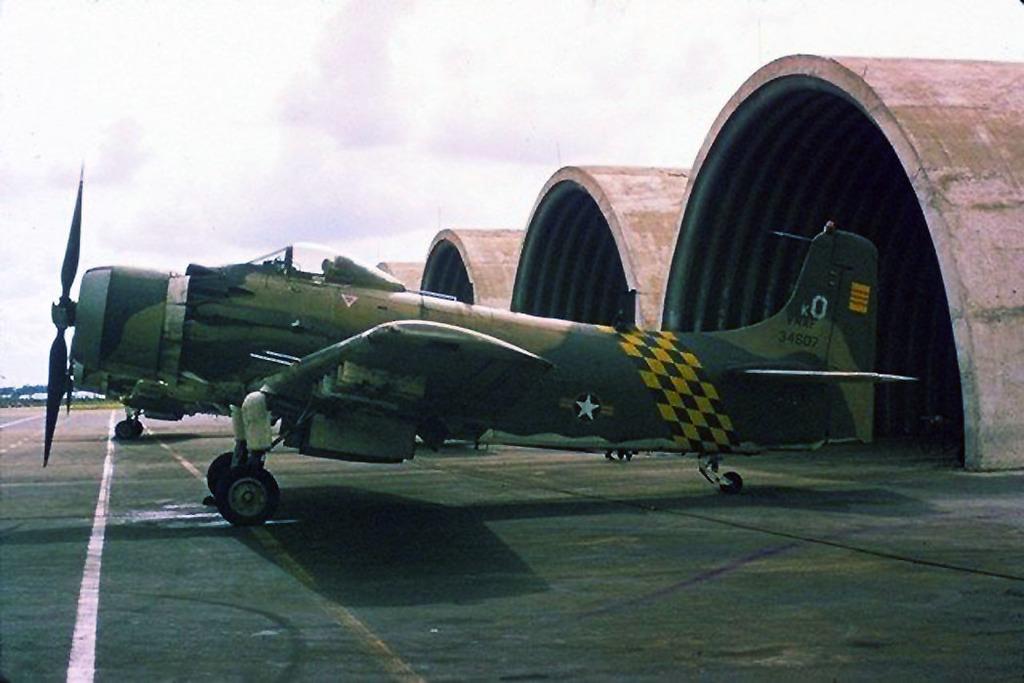What is the small white letter?
Offer a terse response. K. 